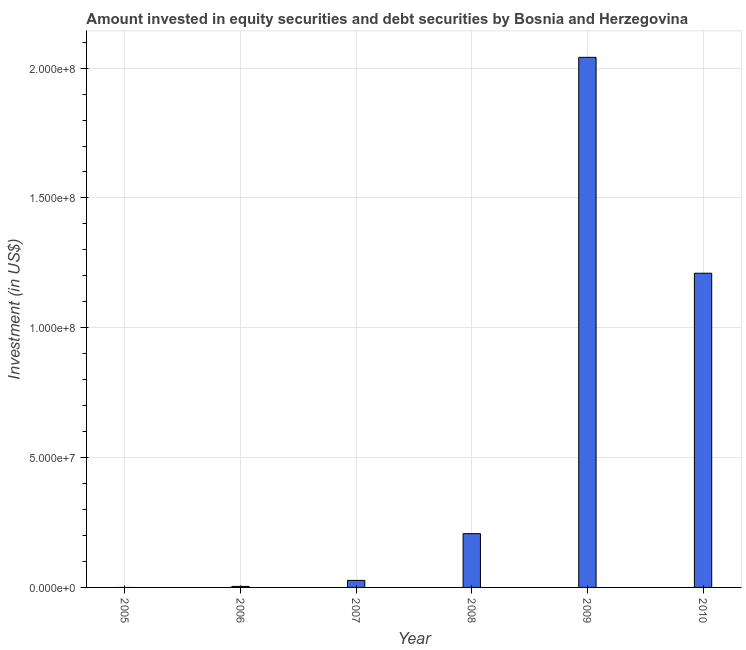Does the graph contain any zero values?
Provide a succinct answer. Yes. Does the graph contain grids?
Provide a short and direct response. Yes. What is the title of the graph?
Keep it short and to the point. Amount invested in equity securities and debt securities by Bosnia and Herzegovina. What is the label or title of the Y-axis?
Keep it short and to the point. Investment (in US$). What is the portfolio investment in 2007?
Give a very brief answer. 2.70e+06. Across all years, what is the maximum portfolio investment?
Your response must be concise. 2.04e+08. Across all years, what is the minimum portfolio investment?
Offer a terse response. 0. What is the sum of the portfolio investment?
Ensure brevity in your answer.  3.49e+08. What is the difference between the portfolio investment in 2006 and 2007?
Make the answer very short. -2.31e+06. What is the average portfolio investment per year?
Offer a very short reply. 5.82e+07. What is the median portfolio investment?
Make the answer very short. 1.17e+07. What is the ratio of the portfolio investment in 2006 to that in 2010?
Your answer should be compact. 0. Is the portfolio investment in 2009 less than that in 2010?
Your answer should be compact. No. Is the difference between the portfolio investment in 2008 and 2010 greater than the difference between any two years?
Give a very brief answer. No. What is the difference between the highest and the second highest portfolio investment?
Offer a terse response. 8.31e+07. Is the sum of the portfolio investment in 2007 and 2010 greater than the maximum portfolio investment across all years?
Make the answer very short. No. What is the difference between the highest and the lowest portfolio investment?
Make the answer very short. 2.04e+08. How many bars are there?
Your answer should be very brief. 5. How many years are there in the graph?
Your answer should be very brief. 6. What is the difference between two consecutive major ticks on the Y-axis?
Offer a terse response. 5.00e+07. What is the Investment (in US$) in 2005?
Offer a terse response. 0. What is the Investment (in US$) in 2006?
Ensure brevity in your answer.  3.88e+05. What is the Investment (in US$) in 2007?
Keep it short and to the point. 2.70e+06. What is the Investment (in US$) of 2008?
Make the answer very short. 2.07e+07. What is the Investment (in US$) in 2009?
Give a very brief answer. 2.04e+08. What is the Investment (in US$) in 2010?
Offer a very short reply. 1.21e+08. What is the difference between the Investment (in US$) in 2006 and 2007?
Keep it short and to the point. -2.31e+06. What is the difference between the Investment (in US$) in 2006 and 2008?
Provide a short and direct response. -2.03e+07. What is the difference between the Investment (in US$) in 2006 and 2009?
Provide a succinct answer. -2.04e+08. What is the difference between the Investment (in US$) in 2006 and 2010?
Provide a succinct answer. -1.21e+08. What is the difference between the Investment (in US$) in 2007 and 2008?
Offer a very short reply. -1.80e+07. What is the difference between the Investment (in US$) in 2007 and 2009?
Ensure brevity in your answer.  -2.01e+08. What is the difference between the Investment (in US$) in 2007 and 2010?
Keep it short and to the point. -1.18e+08. What is the difference between the Investment (in US$) in 2008 and 2009?
Your response must be concise. -1.83e+08. What is the difference between the Investment (in US$) in 2008 and 2010?
Keep it short and to the point. -1.00e+08. What is the difference between the Investment (in US$) in 2009 and 2010?
Ensure brevity in your answer.  8.31e+07. What is the ratio of the Investment (in US$) in 2006 to that in 2007?
Make the answer very short. 0.14. What is the ratio of the Investment (in US$) in 2006 to that in 2008?
Make the answer very short. 0.02. What is the ratio of the Investment (in US$) in 2006 to that in 2009?
Ensure brevity in your answer.  0. What is the ratio of the Investment (in US$) in 2006 to that in 2010?
Your answer should be compact. 0. What is the ratio of the Investment (in US$) in 2007 to that in 2008?
Make the answer very short. 0.13. What is the ratio of the Investment (in US$) in 2007 to that in 2009?
Your answer should be very brief. 0.01. What is the ratio of the Investment (in US$) in 2007 to that in 2010?
Offer a very short reply. 0.02. What is the ratio of the Investment (in US$) in 2008 to that in 2009?
Provide a short and direct response. 0.1. What is the ratio of the Investment (in US$) in 2008 to that in 2010?
Make the answer very short. 0.17. What is the ratio of the Investment (in US$) in 2009 to that in 2010?
Keep it short and to the point. 1.69. 